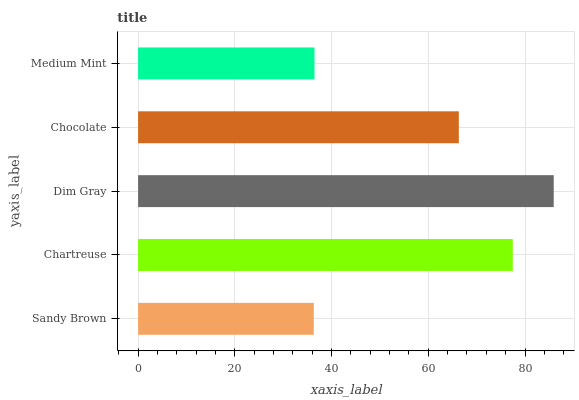Is Sandy Brown the minimum?
Answer yes or no. Yes. Is Dim Gray the maximum?
Answer yes or no. Yes. Is Chartreuse the minimum?
Answer yes or no. No. Is Chartreuse the maximum?
Answer yes or no. No. Is Chartreuse greater than Sandy Brown?
Answer yes or no. Yes. Is Sandy Brown less than Chartreuse?
Answer yes or no. Yes. Is Sandy Brown greater than Chartreuse?
Answer yes or no. No. Is Chartreuse less than Sandy Brown?
Answer yes or no. No. Is Chocolate the high median?
Answer yes or no. Yes. Is Chocolate the low median?
Answer yes or no. Yes. Is Chartreuse the high median?
Answer yes or no. No. Is Medium Mint the low median?
Answer yes or no. No. 